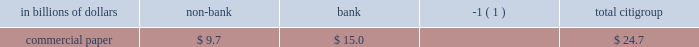Secured financing is primarily conducted through citi 2019s broker-dealer subsidiaries to facilitate customer matched-book activity and to efficiently fund a portion of the trading inventory .
Secured financing appears as a liability on citi 2019s consolidated balance sheet ( 201csecurities loaned or sold under agreements to repurchase 201d ) .
As of december 31 , 2010 , secured financing was $ 189.6 billion and averaged approximately $ 207 billion during the quarter ended december 31 , 2010 .
Secured financing at december 31 , 2010 increased by $ 35 billion from $ 154.3 billion at december 31 , 2009 .
During the same period , reverse repos and securities borrowing increased by $ 25 billion .
The majority of secured financing is collateralized by highly liquid government , government-backed and government agency securities .
This collateral comes primarily from citi 2019s trading assets and its secured lending , and is part of citi 2019s client matched-book activity given that citi both borrows and lends similar asset types on a secured basis .
The minority of secured financing is collateralized by less liquid collateral , and supports both citi 2019s trading assets as well as the business of secured lending to customers , which is also part of citi 2019s client matched-book activity .
The less liquid secured borrowing is carefully calibrated by asset quality , tenor and counterparty exposure , including those that might be sensitive to ratings stresses , in order to increase the reliability of the funding .
Citi believes there are several potential mitigants available to it in the event of stress on the secured financing markets for less liquid collateral .
Citi 2019s significant liquidity resources in its non-bank entities as of december 31 , 2010 , supplemented by collateralized liquidity transfers between entities , provide a cushion .
Within the matched-book activity , the secured lending positions , which are carefully managed in terms of collateral and tenor , could be unwound to provide additional liquidity under stress .
Citi also has excess funding capacity for less liquid collateral with existing counterparties that can be accessed during potential dislocation .
In addition , citi has the ability to adjust the size of select trading books to provide further mitigation .
At december 31 , 2010 , commercial paper outstanding for citigroup 2019s non- bank entities and bank subsidiaries , respectively , was as follows : in billions of dollars non-bank bank ( 1 ) citigroup .
( 1 ) includes $ 15 billion of commercial paper related to vies consolidated effective january 1 , 2010 with the adoption of sfas 166/167 .
Other short-term borrowings of approximately $ 54 billion ( as set forth in the secured financing and short-term borrowings table above ) include $ 42.4 billion of borrowings from banks and other market participants , which includes borrowings from the federal home loan banks .
This represented a decrease of approximately $ 11 billion as compared to year-end 2009 .
The average balance of borrowings from banks and other market participants for the quarter ended december 31 , 2010 was approximately $ 43 billion .
Other short-term borrowings also include $ 11.7 billion of broker borrowings at december 31 , 2010 , which averaged approximately $ 13 billion for the quarter ended december 31 , 2010 .
See notes 12 and 19 to the consolidated financial statements for further information on citigroup 2019s and its affiliates 2019 outstanding long-term debt and short-term borrowings .
Liquidity transfer between entities liquidity is generally transferable within the non-bank , subject to regulatory restrictions ( if any ) and standard legal terms .
Similarly , the non-bank can generally transfer excess liquidity into citi 2019s bank subsidiaries , such as citibank , n.a .
In addition , citigroup 2019s bank subsidiaries , including citibank , n.a. , can lend to the citigroup parent and broker-dealer in accordance with section 23a of the federal reserve act .
As of december 31 , 2010 , the amount available for lending under section 23a was approximately $ 26.6 billion , provided the funds are collateralized appropriately. .
What percentage of commercial paper outstanding as of december 31 , 2010 was for bank subsidiaries? 
Computations: (15.0 / 24.7)
Answer: 0.60729. 